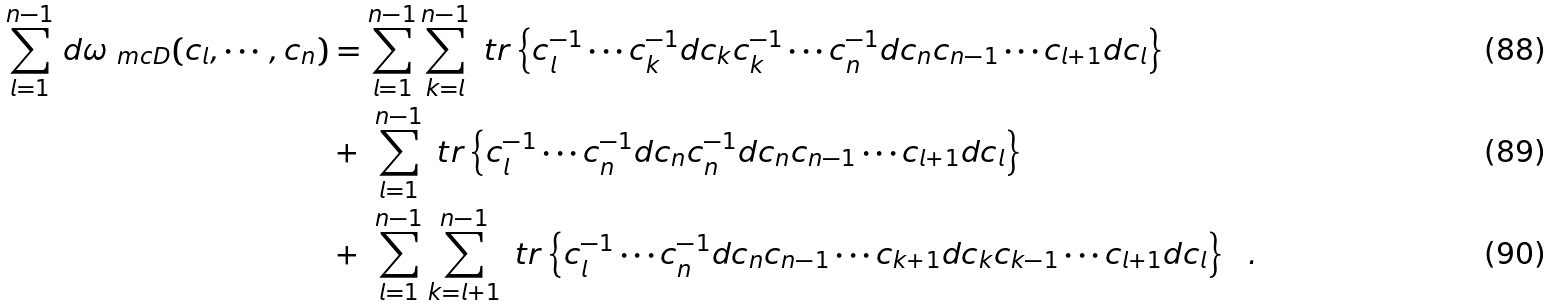<formula> <loc_0><loc_0><loc_500><loc_500>\sum _ { l = 1 } ^ { n - 1 } \, d \omega _ { \ m c { D } } ( c _ { l } , \cdots , c _ { n } ) & = \sum _ { l = 1 } ^ { n - 1 } \sum _ { k = l } ^ { n - 1 } \ t r \left \{ c _ { l } ^ { - 1 } \cdots c _ { k } ^ { - 1 } d c _ { k } c _ { k } ^ { - 1 } \cdots c _ { n } ^ { - 1 } d c _ { n } c _ { n - 1 } \cdots c _ { l + 1 } d c _ { l } \right \} \\ & + \ \sum _ { l = 1 } ^ { n - 1 } \ t r \left \{ c _ { l } ^ { - 1 } \cdots c _ { n } ^ { - 1 } d c _ { n } c _ { n } ^ { - 1 } d c _ { n } c _ { n - 1 } \cdots c _ { l + 1 } d c _ { l } \right \} \\ & + \ \sum _ { l = 1 } ^ { n - 1 } \sum _ { k = l + 1 } ^ { n - 1 } \ t r \left \{ c _ { l } ^ { - 1 } \cdots c _ { n } ^ { - 1 } d c _ { n } c _ { n - 1 } \cdots c _ { k + 1 } d c _ { k } c _ { k - 1 } \cdots c _ { l + 1 } d c _ { l } \right \} \ \ .</formula> 